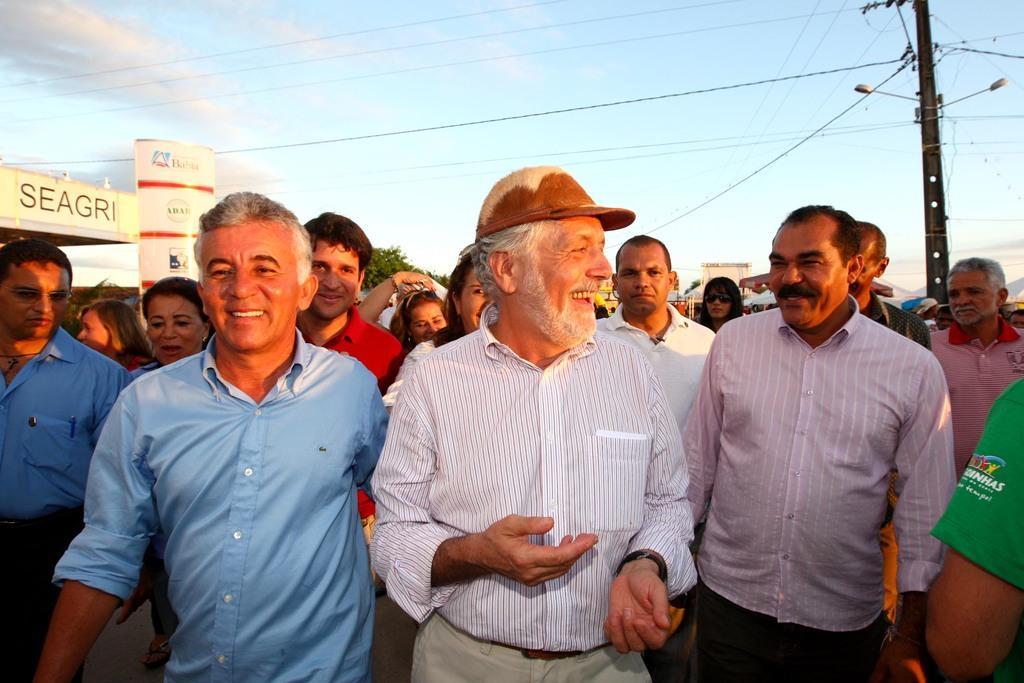Describe this image in one or two sentences. This image is taken outdoors. At the top of the image there is a sky with clouds. In the background there are a few buildings and trees and a pole with a few wires and street lights. On the left side of the image there are a few boards with text on them. In the middle of the image many people are walking on the road. 